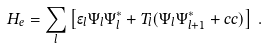Convert formula to latex. <formula><loc_0><loc_0><loc_500><loc_500>H _ { e } = \sum _ { l } \left [ \epsilon _ { l } \Psi _ { l } \Psi _ { l } ^ { * } + T _ { l } ( \Psi _ { l } \Psi _ { l + 1 } ^ { * } + c c ) \right ] \, .</formula> 